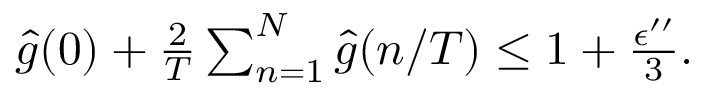Convert formula to latex. <formula><loc_0><loc_0><loc_500><loc_500>\begin{array} { r } { \hat { g } ( 0 ) + \frac { 2 } { T } \sum _ { n = 1 } ^ { N } \hat { g } ( n / T ) \leq 1 + \frac { \epsilon ^ { \prime \prime } } { 3 } . } \end{array}</formula> 